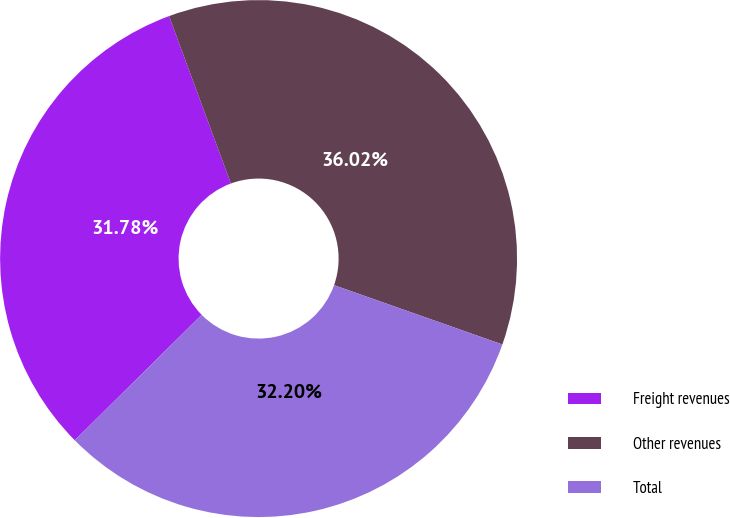Convert chart. <chart><loc_0><loc_0><loc_500><loc_500><pie_chart><fcel>Freight revenues<fcel>Other revenues<fcel>Total<nl><fcel>31.78%<fcel>36.02%<fcel>32.2%<nl></chart> 